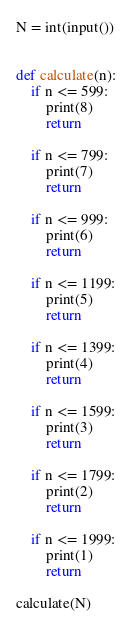<code> <loc_0><loc_0><loc_500><loc_500><_Python_>N = int(input())


def calculate(n):
    if n <= 599:
        print(8)
        return

    if n <= 799:
        print(7)
        return

    if n <= 999:
        print(6)
        return

    if n <= 1199:
        print(5)
        return

    if n <= 1399:
        print(4)
        return

    if n <= 1599:
        print(3)
        return

    if n <= 1799:
        print(2)
        return

    if n <= 1999:
        print(1)
        return

calculate(N)</code> 